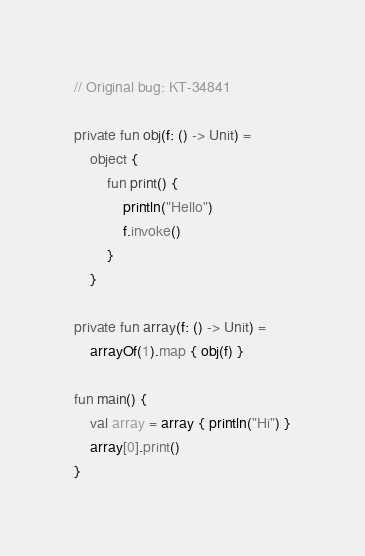Convert code to text. <code><loc_0><loc_0><loc_500><loc_500><_Kotlin_>// Original bug: KT-34841

private fun obj(f: () -> Unit) =
    object {
        fun print() {
            println("Hello")
            f.invoke()
        }
    }

private fun array(f: () -> Unit) =
    arrayOf(1).map { obj(f) }

fun main() {
    val array = array { println("Hi") }
    array[0].print()
}
</code> 